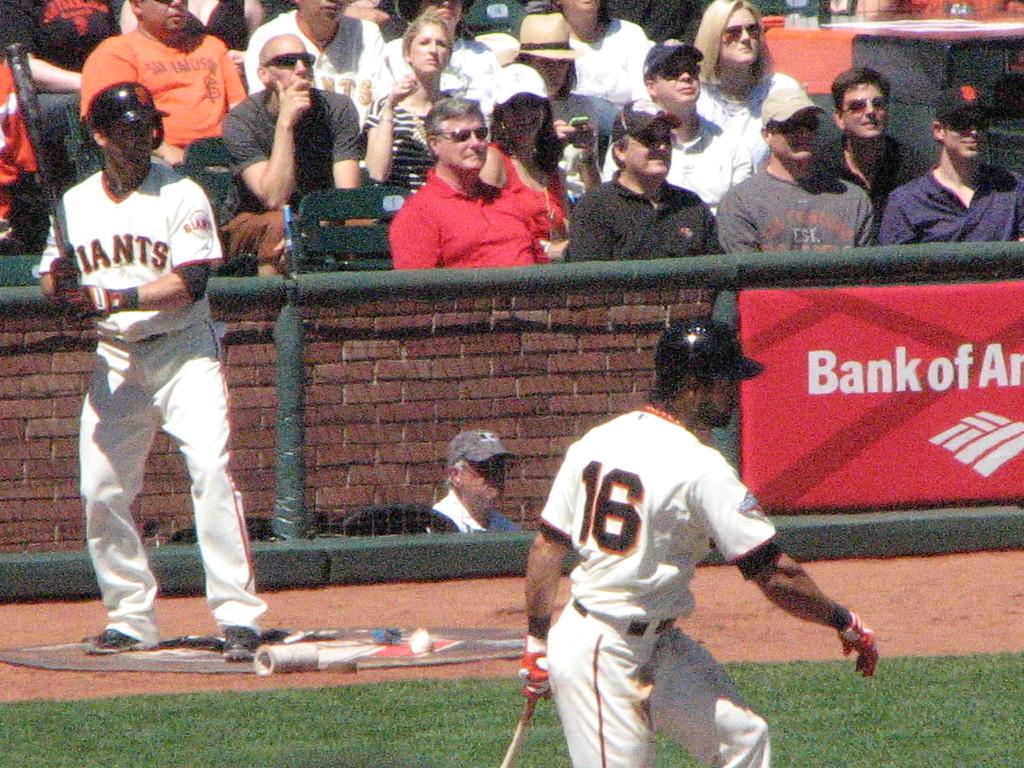What is the name of team on the batters shirt?
Give a very brief answer. Giants. 